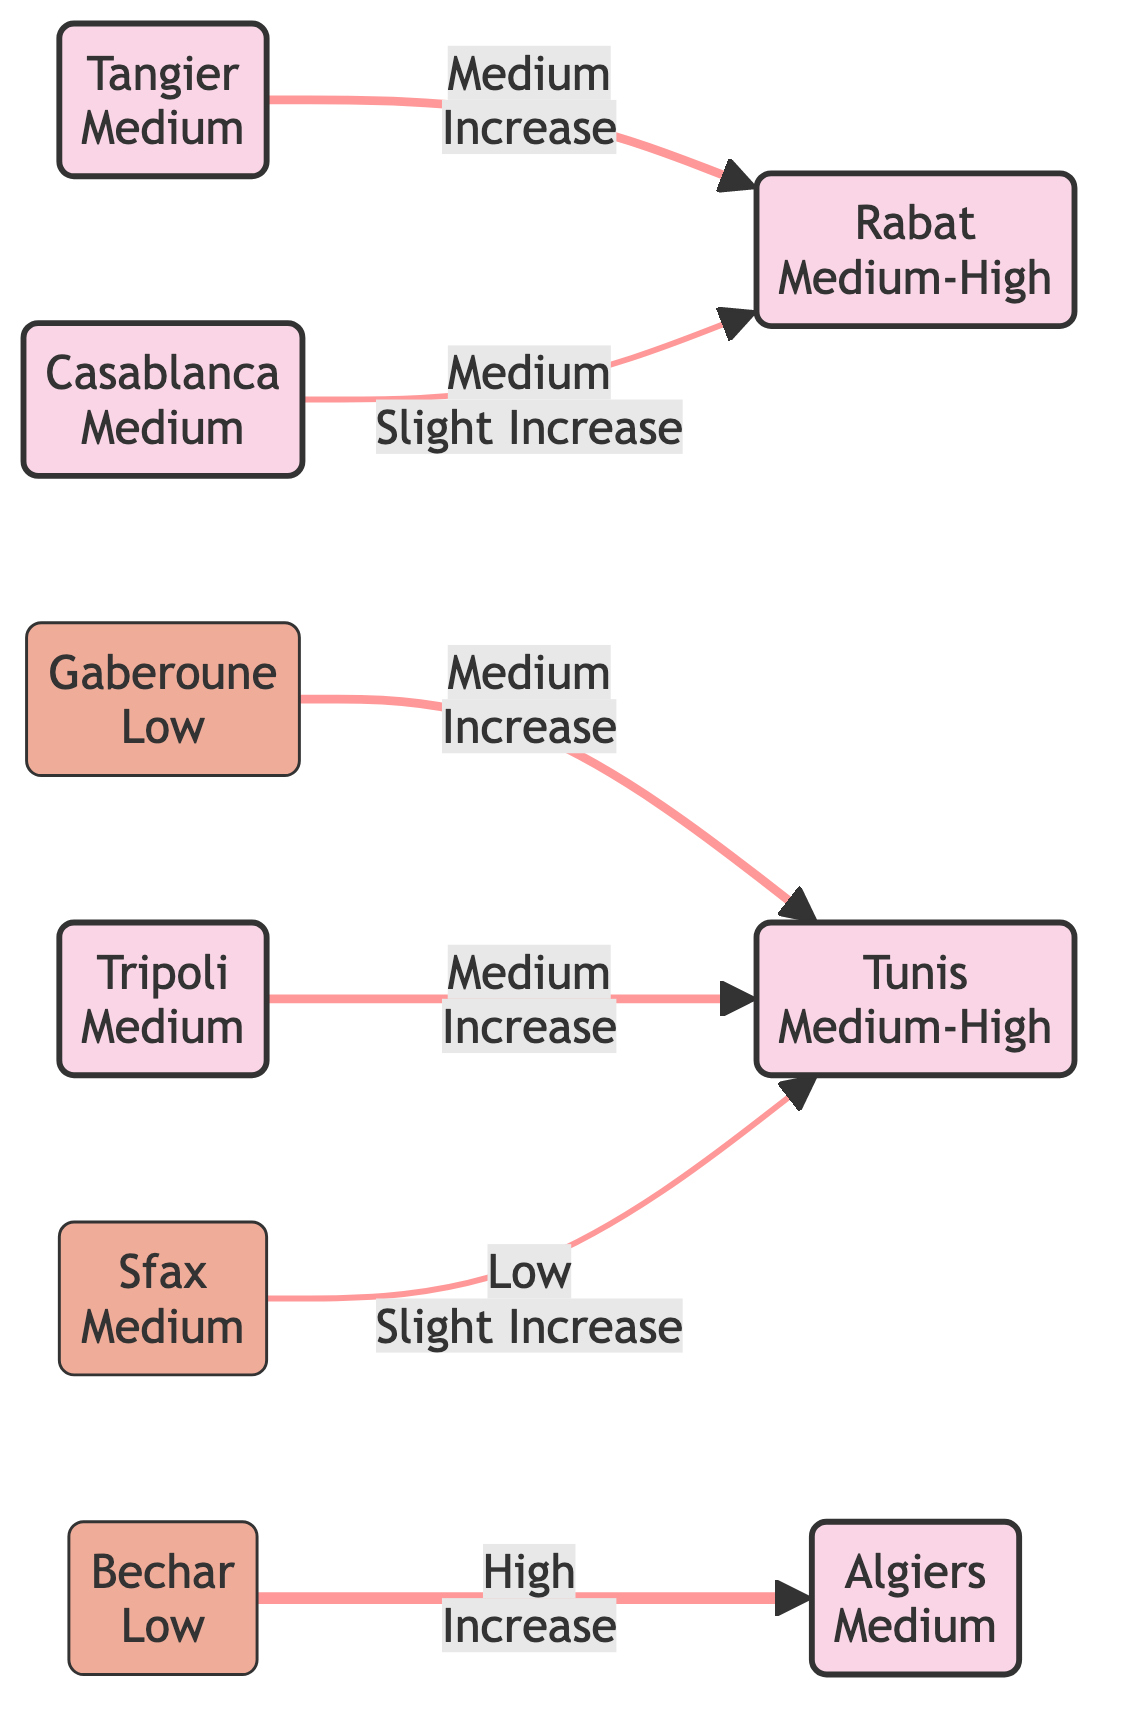What is the income level of Tunis? The diagram specifically states that Tunis has an income level categorized as "Medium-High."
Answer: Medium-High How many major cities are represented in the graph? By identifying the nodes tagged as "Major City," we can count a total of 6 cities: Algiers, Tunis, Casablanca, Rabat, Tripoli, and Tangier.
Answer: 6 What is the migrant flow from Bechar to Algiers? The edge connecting Bechar to Algiers indicates a "High" migrant flow.
Answer: High Which city has a slight increase in income when migrants flow from Casablanca? The flow from Casablanca goes to Rabat, and the diagram notes an income change as "Slight Increase" therefore, Rabat is the city with a slight increase in income.
Answer: Rabat How many total migration routes are shown in the diagram? By reviewing the edges, we can see there are 6 migration routes depicted between various nodes.
Answer: 6 Is the income level of Gaberoune lower than that of Tangier? The income level for Gaberoune is categorized as "Low," while Tangier is categorized as "Medium," hence Gaberoune is lower.
Answer: Yes What is the income change for migrants traveling from Tripoli to Tunis? The edge from Tripoli to Tunis identifies an "Increase" in income as a result of the migrant flow.
Answer: Increase What type of relationship exists between Sfax and Tunis in terms of migrant flow? The diagram shows that the relationship has a "Low" migrant flow from Sfax to Tunis, indicating a minimal level of movement.
Answer: Low What is the income level of cities that receive high migrant flows in this diagram? Both Algiers and Tunis receive high or moderate migrant flows, with income levels of Medium-High and Medium, respectively.
Answer: Medium-High, Medium 